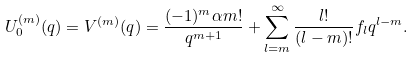<formula> <loc_0><loc_0><loc_500><loc_500>U _ { 0 } ^ { ( m ) } ( q ) = V ^ { ( m ) } ( q ) = \frac { ( - 1 ) ^ { m } \alpha m ! } { q ^ { m + 1 } } + \sum _ { l = m } ^ { \infty } \frac { l ! } { ( l - m ) ! } f _ { l } q ^ { l - m } .</formula> 